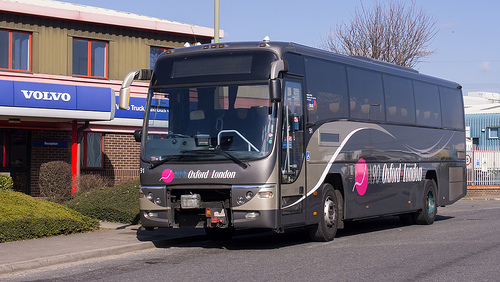Please provide a short description for this region: [0.23, 0.35, 0.3, 0.44]. A close-up of a silver side view mirror on a transit vehicle, featuring some minor scratches and providing a crucial visibility tool for the driver. 